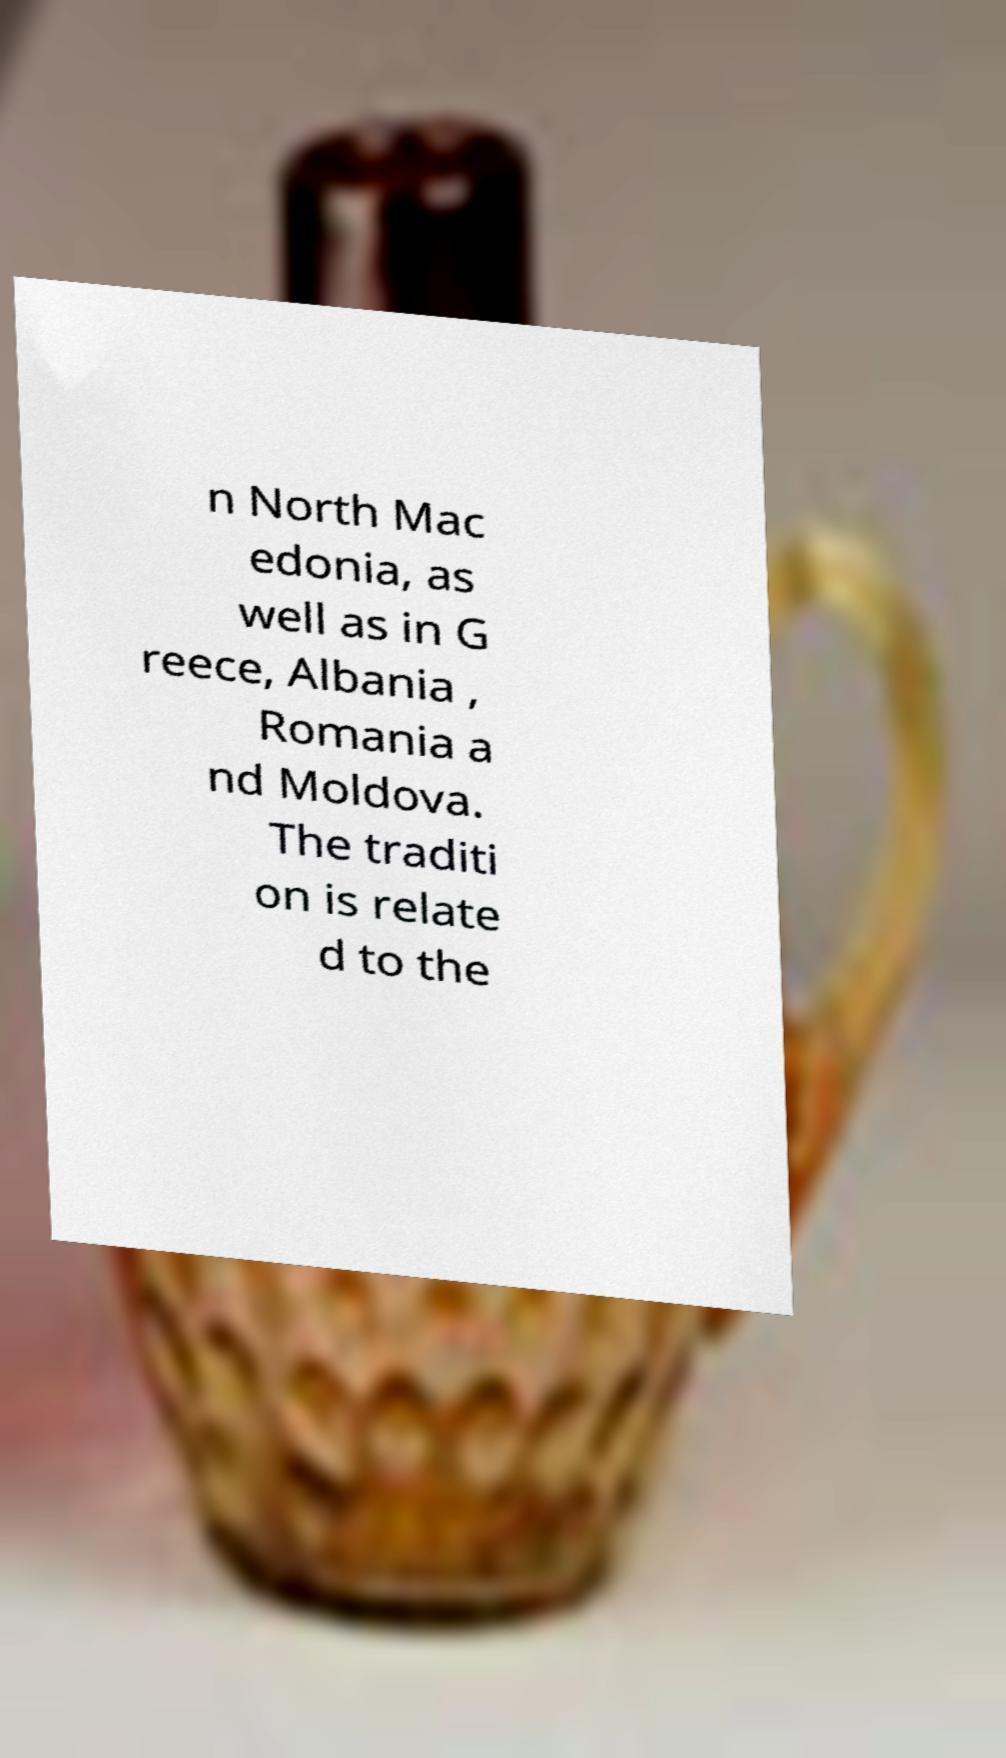Please read and relay the text visible in this image. What does it say? n North Mac edonia, as well as in G reece, Albania , Romania a nd Moldova. The traditi on is relate d to the 